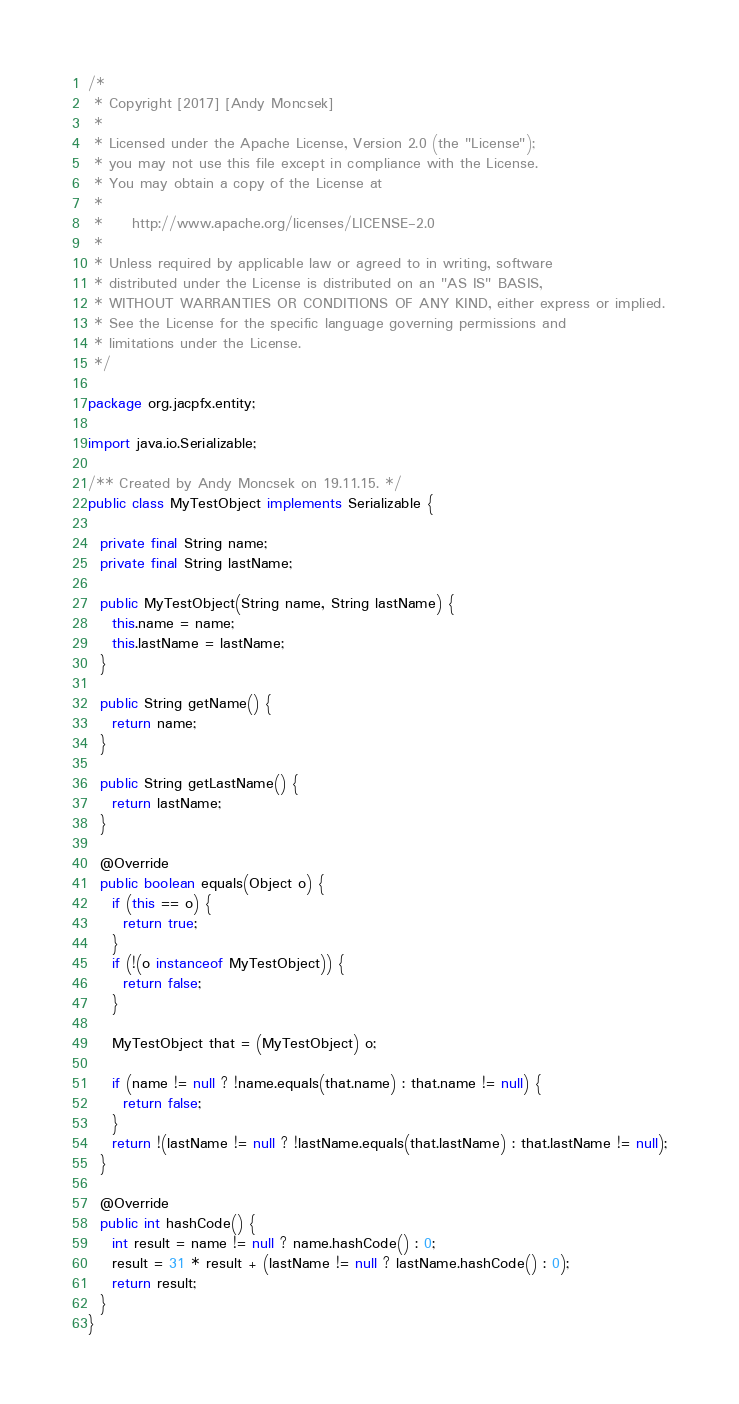Convert code to text. <code><loc_0><loc_0><loc_500><loc_500><_Java_>/*
 * Copyright [2017] [Andy Moncsek]
 *
 * Licensed under the Apache License, Version 2.0 (the "License");
 * you may not use this file except in compliance with the License.
 * You may obtain a copy of the License at
 *
 *     http://www.apache.org/licenses/LICENSE-2.0
 *
 * Unless required by applicable law or agreed to in writing, software
 * distributed under the License is distributed on an "AS IS" BASIS,
 * WITHOUT WARRANTIES OR CONDITIONS OF ANY KIND, either express or implied.
 * See the License for the specific language governing permissions and
 * limitations under the License.
 */

package org.jacpfx.entity;

import java.io.Serializable;

/** Created by Andy Moncsek on 19.11.15. */
public class MyTestObject implements Serializable {

  private final String name;
  private final String lastName;

  public MyTestObject(String name, String lastName) {
    this.name = name;
    this.lastName = lastName;
  }

  public String getName() {
    return name;
  }

  public String getLastName() {
    return lastName;
  }

  @Override
  public boolean equals(Object o) {
    if (this == o) {
      return true;
    }
    if (!(o instanceof MyTestObject)) {
      return false;
    }

    MyTestObject that = (MyTestObject) o;

    if (name != null ? !name.equals(that.name) : that.name != null) {
      return false;
    }
    return !(lastName != null ? !lastName.equals(that.lastName) : that.lastName != null);
  }

  @Override
  public int hashCode() {
    int result = name != null ? name.hashCode() : 0;
    result = 31 * result + (lastName != null ? lastName.hashCode() : 0);
    return result;
  }
}
</code> 